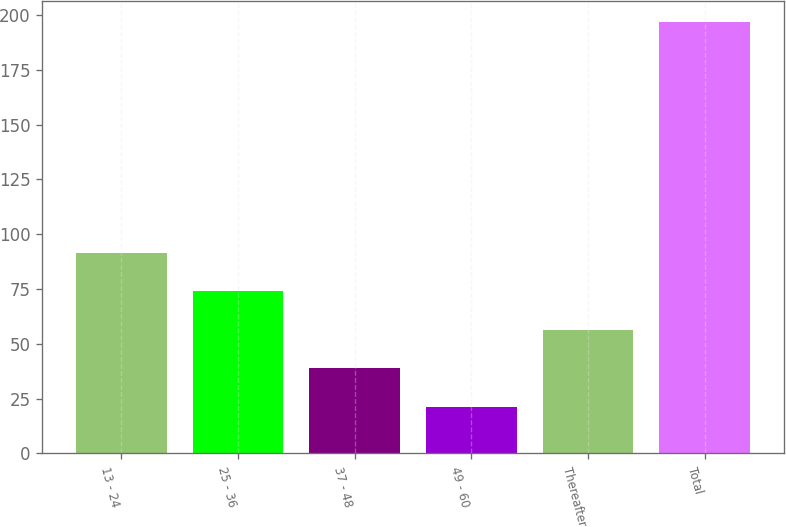Convert chart to OTSL. <chart><loc_0><loc_0><loc_500><loc_500><bar_chart><fcel>13 - 24<fcel>25 - 36<fcel>37 - 48<fcel>49 - 60<fcel>Thereafter<fcel>Total<nl><fcel>91.48<fcel>73.96<fcel>38.92<fcel>21.4<fcel>56.44<fcel>196.6<nl></chart> 